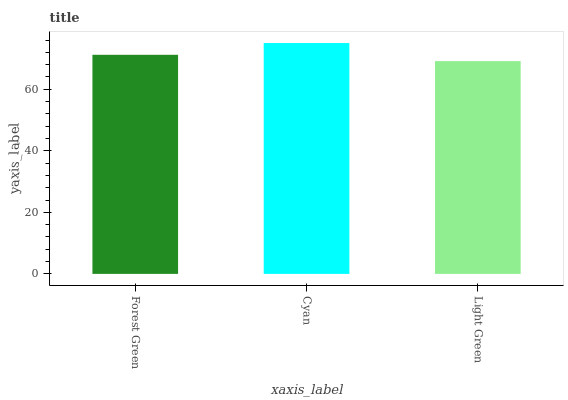Is Cyan the minimum?
Answer yes or no. No. Is Light Green the maximum?
Answer yes or no. No. Is Cyan greater than Light Green?
Answer yes or no. Yes. Is Light Green less than Cyan?
Answer yes or no. Yes. Is Light Green greater than Cyan?
Answer yes or no. No. Is Cyan less than Light Green?
Answer yes or no. No. Is Forest Green the high median?
Answer yes or no. Yes. Is Forest Green the low median?
Answer yes or no. Yes. Is Light Green the high median?
Answer yes or no. No. Is Light Green the low median?
Answer yes or no. No. 